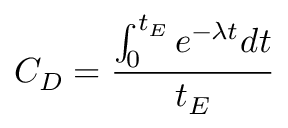Convert formula to latex. <formula><loc_0><loc_0><loc_500><loc_500>C _ { D } = \frac { \int _ { 0 } ^ { t _ { E } } e ^ { - { \lambda } t } d t } { t _ { E } }</formula> 